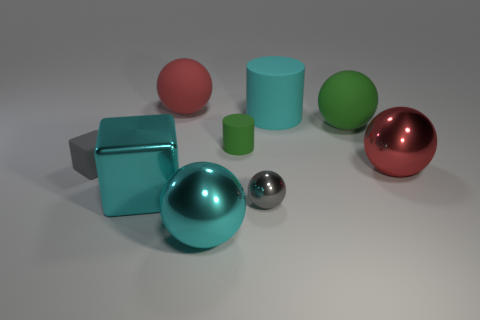Subtract all green cubes. How many red spheres are left? 2 Subtract all large cyan balls. How many balls are left? 4 Subtract 3 balls. How many balls are left? 2 Add 1 tiny yellow cylinders. How many objects exist? 10 Subtract all green spheres. How many spheres are left? 4 Subtract all cubes. How many objects are left? 7 Subtract all brown spheres. Subtract all cyan cubes. How many spheres are left? 5 Subtract 2 red spheres. How many objects are left? 7 Subtract all blue matte balls. Subtract all small gray matte objects. How many objects are left? 8 Add 6 big cyan shiny cubes. How many big cyan shiny cubes are left? 7 